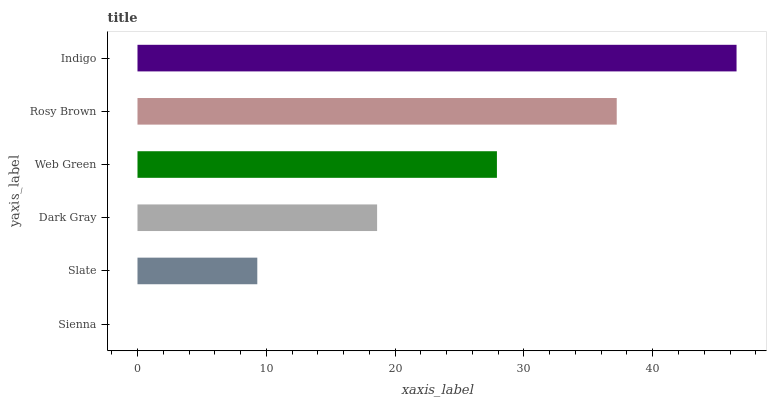Is Sienna the minimum?
Answer yes or no. Yes. Is Indigo the maximum?
Answer yes or no. Yes. Is Slate the minimum?
Answer yes or no. No. Is Slate the maximum?
Answer yes or no. No. Is Slate greater than Sienna?
Answer yes or no. Yes. Is Sienna less than Slate?
Answer yes or no. Yes. Is Sienna greater than Slate?
Answer yes or no. No. Is Slate less than Sienna?
Answer yes or no. No. Is Web Green the high median?
Answer yes or no. Yes. Is Dark Gray the low median?
Answer yes or no. Yes. Is Indigo the high median?
Answer yes or no. No. Is Rosy Brown the low median?
Answer yes or no. No. 